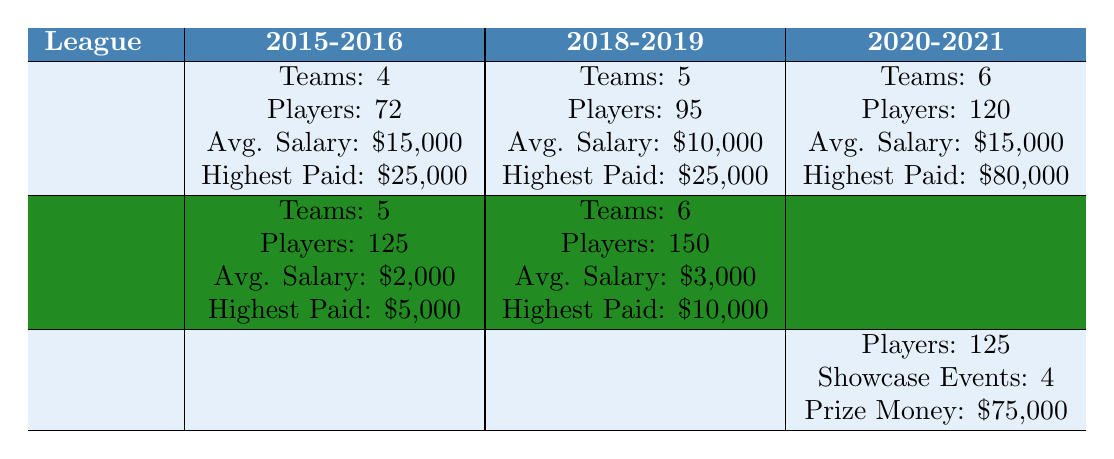What was the highest paid player in the NWHL for the 2020-2021 season? The table indicates that the highest paid player in the NWHL for the 2020-2021 season was paid $80,000.
Answer: $80,000 How many total players were in the CWHL in 2018-2019? According to the table, the total number of players in the CWHL for the 2018-2019 season was 150.
Answer: 150 What was the average salary of players in the NWHL during the 2018-2019 season? The table shows that the average salary for players in the NWHL in the 2018-2019 season was $10,000.
Answer: $10,000 Did the CWHL have more teams in 2015-2016 or 2018-2019? The CWHL had 5 teams in 2015-2016 and 6 teams in 2018-2019, indicating it had more teams in 2018-2019.
Answer: Yes What is the total number of players across all seasons in the NWHL shown? Adding the total players for each season: 72 (2015-2016) + 95 (2018-2019) + 120 (2020-2021) gives a total of 287 players.
Answer: 287 Was the average salary in the CWHL higher in 2018-2019 compared to 2015-2016? In 2015-2016 the average salary was $2,000 and in 2018-2019 it was $3,000, showing that the average salary increased.
Answer: Yes How much total prize money was awarded in the PWHPA during the 2020-2021 season? The table states that the total prize money awarded in the PWHPA for the 2020-2021 season was $75,000.
Answer: $75,000 In which year did the CWHL reportedly fold? The table indicates that the CWHL folded in 2019.
Answer: 2019 What is the difference in the number of teams in the NWHL between the 2018-2019 season and the 2020-2021 season? The NWHL had 5 teams in 2018-2019 and 6 teams in 2020-2021, so the difference in the number of teams is 6 - 5 = 1.
Answer: 1 Which league had the most total players in 2015-2016? In 2015-2016, the CWHL had 125 players and the NWHL had 72 players, making the CWHL have more players.
Answer: CWHL What trends can be observed in the growth of media coverage for women's hockey from 2015 to 2021? Media coverage showed a clear upward trend: TV broadcasts increased from 2 (2015) to 15 (2021), online streaming improved from limited to extensive, and social media followers grew from 50,000 to 750,000.
Answer: Significant growth in media coverage 